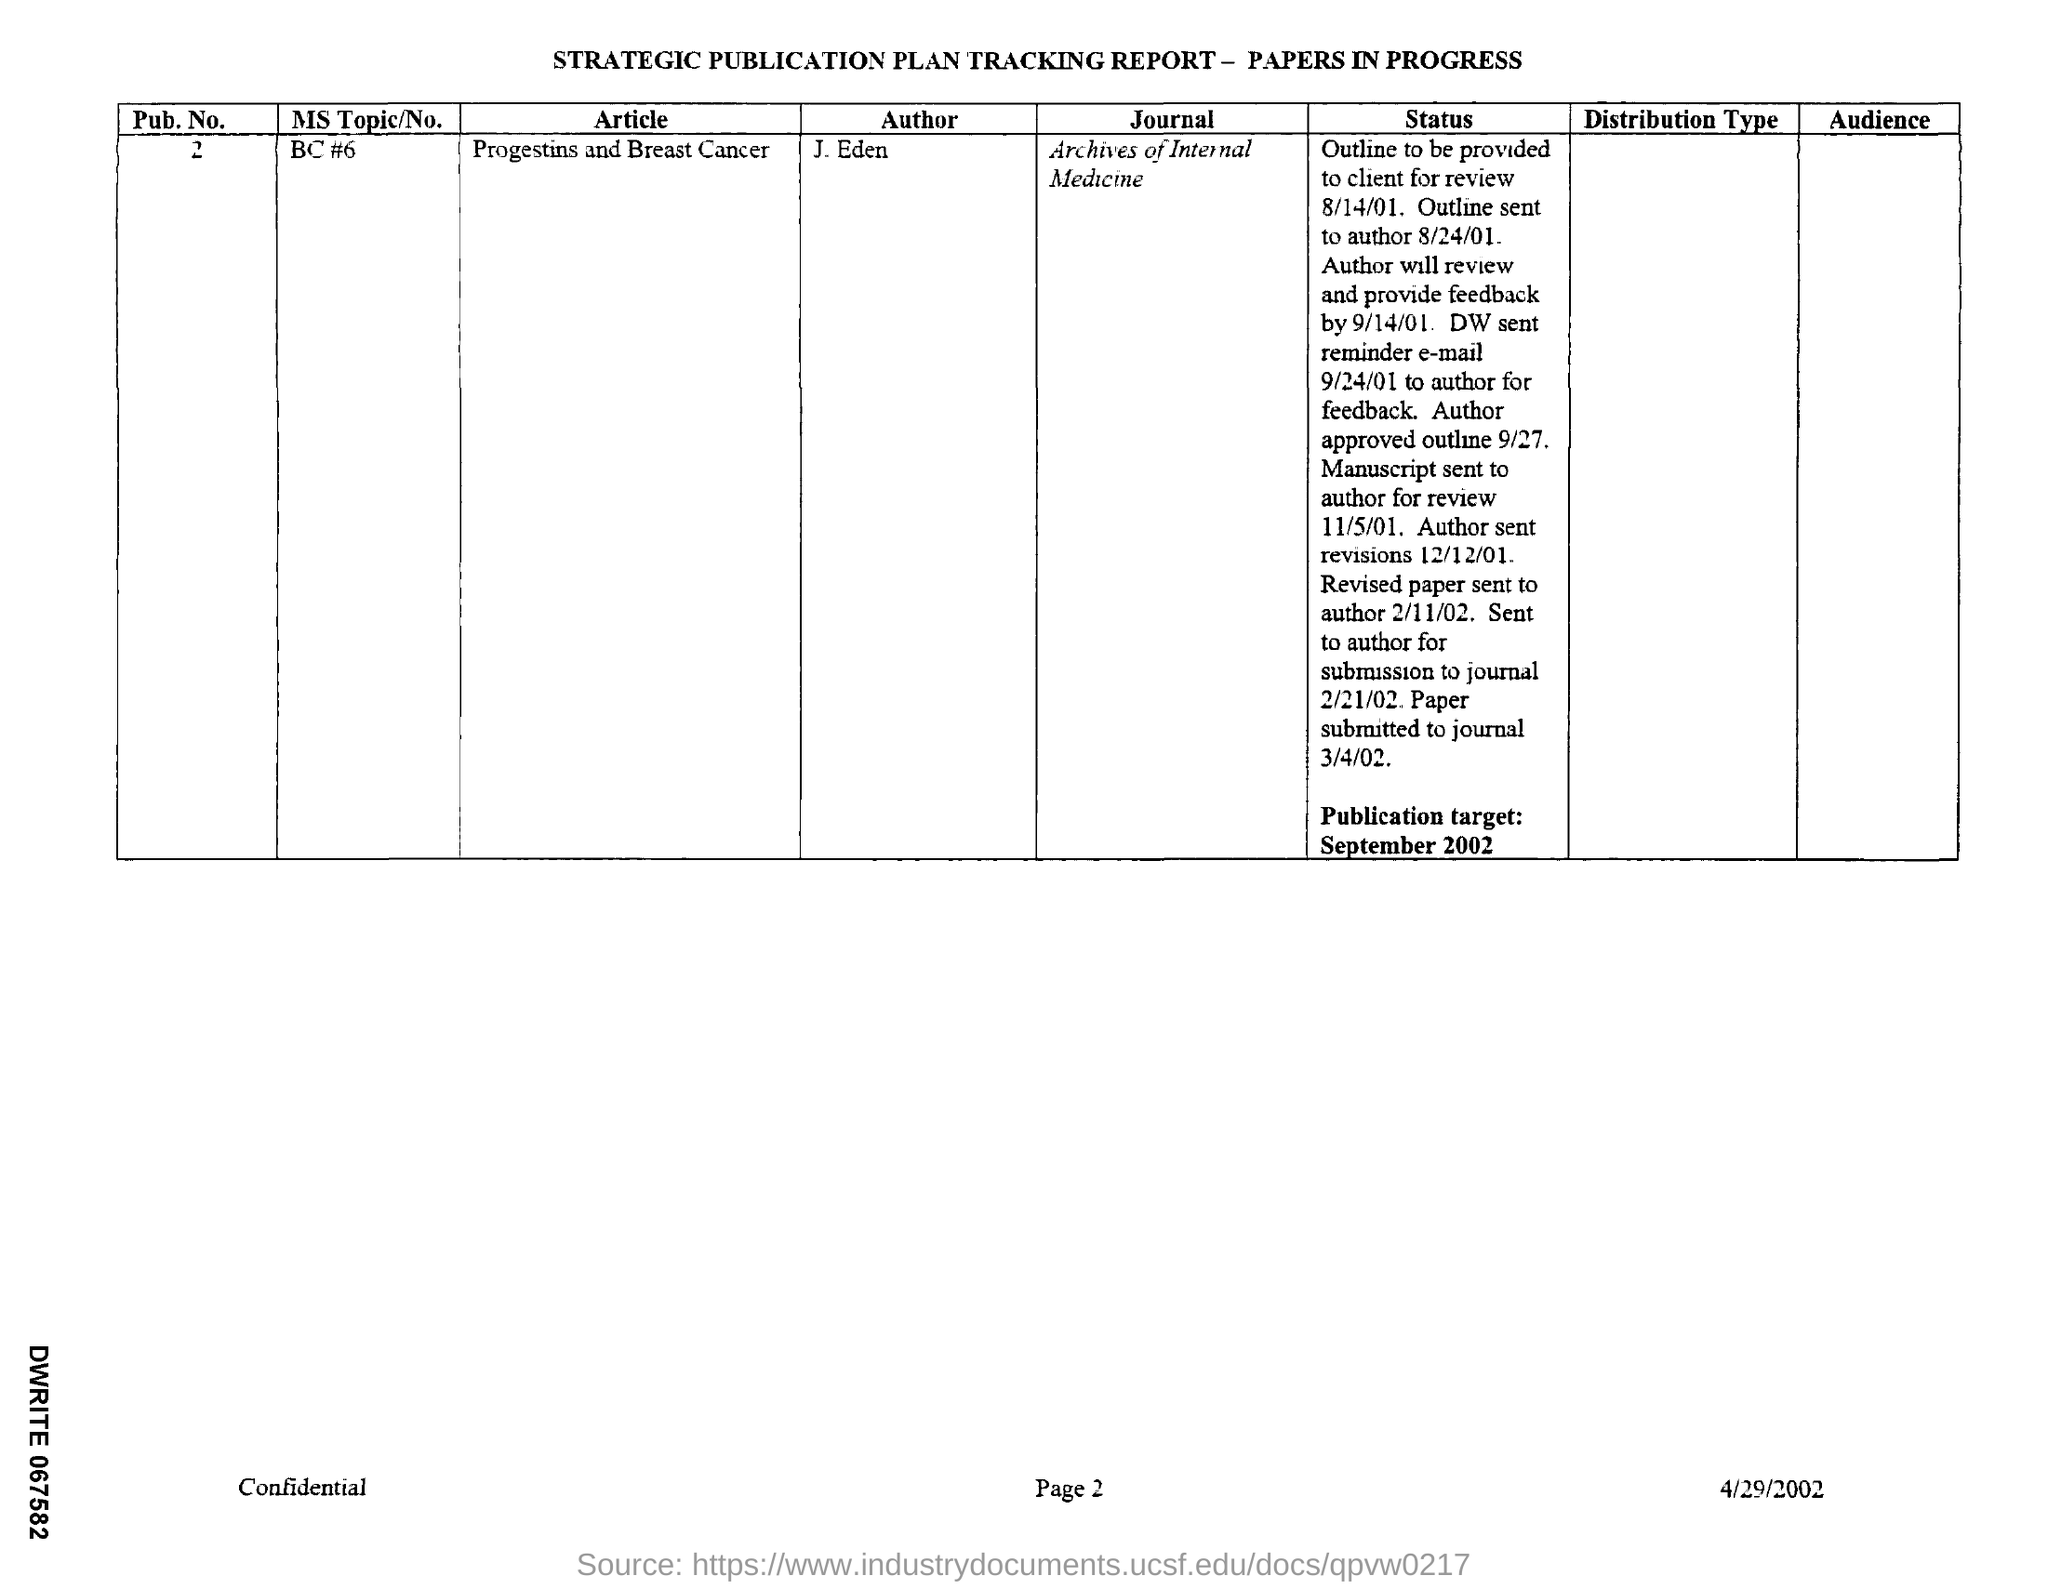What does the 'Status' section tell us about the paper? The 'Status' section reveals the paper's developmental timeline, showing it moved from initial outline review to multiple revisions. Feedback was sought both from the client and the author, with specific details like deadlines for feedback and outline approval, painting a picture of an iterative and collaborative preparation process prior to final submission. Is there any indication of the type of audience intended for this paper? While the document doesn’t explicitly mention the audience type, being published in the 'Archives of Internal Medicine' suggests it is primarily aimed at medical professionals and researchers in the field of internal medicine, particularly those interested in the relationship between progestins and breast cancer. 